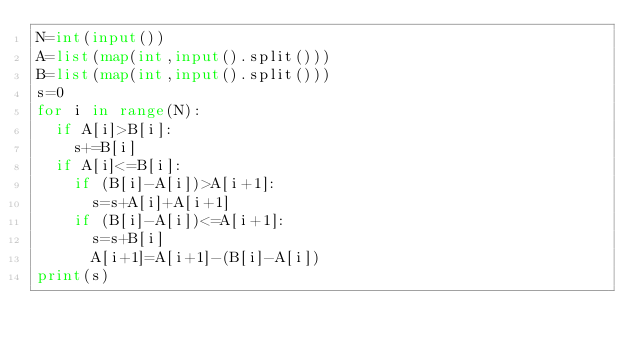Convert code to text. <code><loc_0><loc_0><loc_500><loc_500><_Python_>N=int(input())
A=list(map(int,input().split()))
B=list(map(int,input().split()))
s=0
for i in range(N):
  if A[i]>B[i]:
    s+=B[i]
  if A[i]<=B[i]:
    if (B[i]-A[i])>A[i+1]:
      s=s+A[i]+A[i+1]
    if (B[i]-A[i])<=A[i+1]:
      s=s+B[i]
      A[i+1]=A[i+1]-(B[i]-A[i])
print(s)</code> 